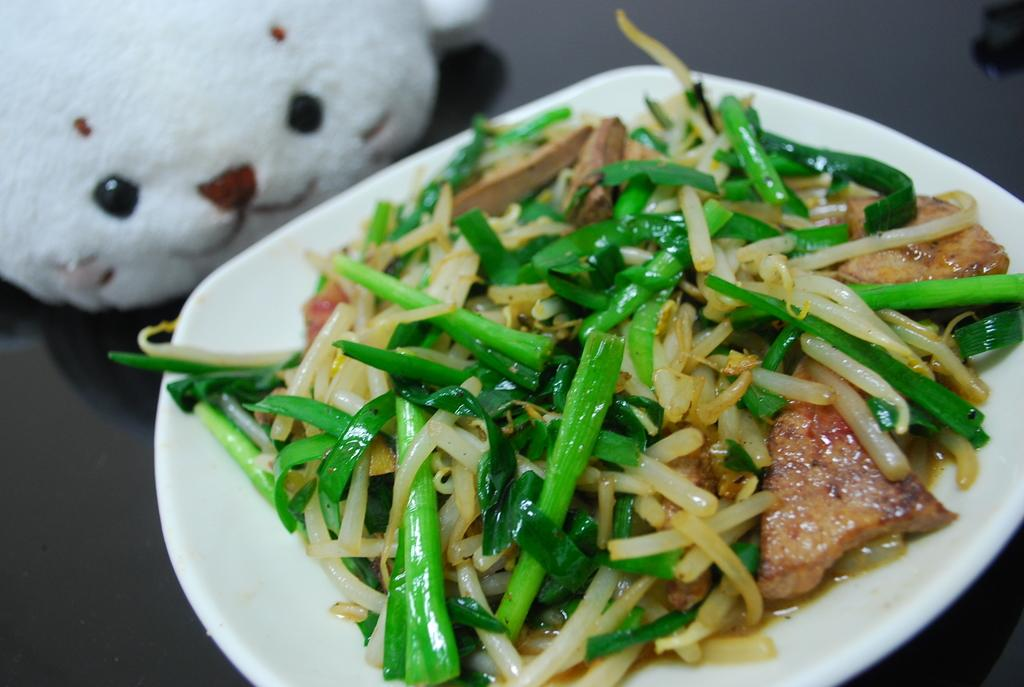What is on the plate that is visible in the image? There is a plate with food in the image. What other object can be seen in the image besides the plate with food? There is a doll on a platform in the image. What type of winter clothing is the doll wearing in the image? There is no winter clothing or any reference to winter in the image; it only features a doll on a platform and a plate with food. 